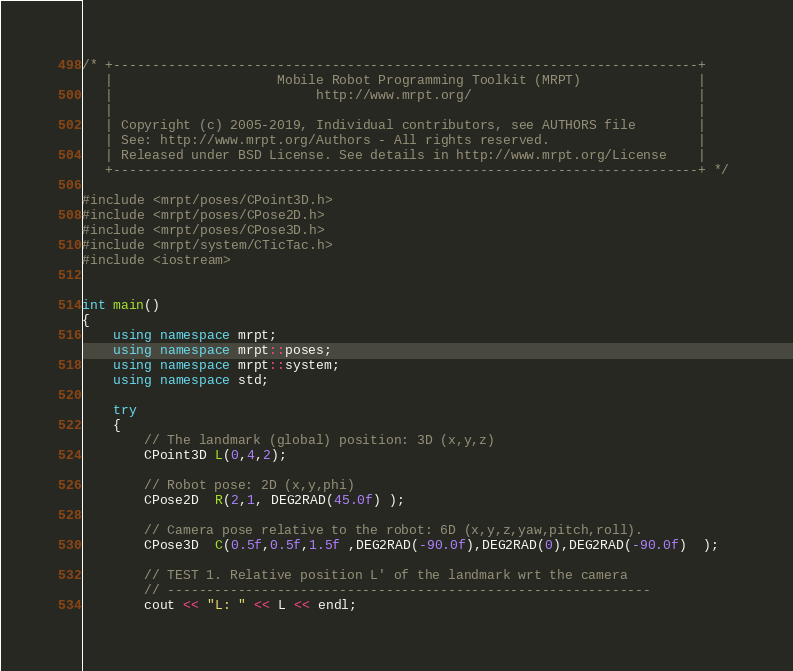Convert code to text. <code><loc_0><loc_0><loc_500><loc_500><_C++_>/* +---------------------------------------------------------------------------+
   |                     Mobile Robot Programming Toolkit (MRPT)               |
   |                          http://www.mrpt.org/                             |
   |                                                                           |
   | Copyright (c) 2005-2019, Individual contributors, see AUTHORS file        |
   | See: http://www.mrpt.org/Authors - All rights reserved.                   |
   | Released under BSD License. See details in http://www.mrpt.org/License    |
   +---------------------------------------------------------------------------+ */

#include <mrpt/poses/CPoint3D.h>
#include <mrpt/poses/CPose2D.h>
#include <mrpt/poses/CPose3D.h>
#include <mrpt/system/CTicTac.h>
#include <iostream>


int main()
{
	using namespace mrpt;
	using namespace mrpt::poses;
	using namespace mrpt::system;
	using namespace std;

	try
	{
		// The landmark (global) position: 3D (x,y,z)
		CPoint3D L(0,4,2);

		// Robot pose: 2D (x,y,phi)
		CPose2D  R(2,1, DEG2RAD(45.0f) );  

		// Camera pose relative to the robot: 6D (x,y,z,yaw,pitch,roll).
		CPose3D  C(0.5f,0.5f,1.5f ,DEG2RAD(-90.0f),DEG2RAD(0),DEG2RAD(-90.0f)  );  

		// TEST 1. Relative position L' of the landmark wrt the camera
		// --------------------------------------------------------------
		cout << "L: " << L << endl;</code> 